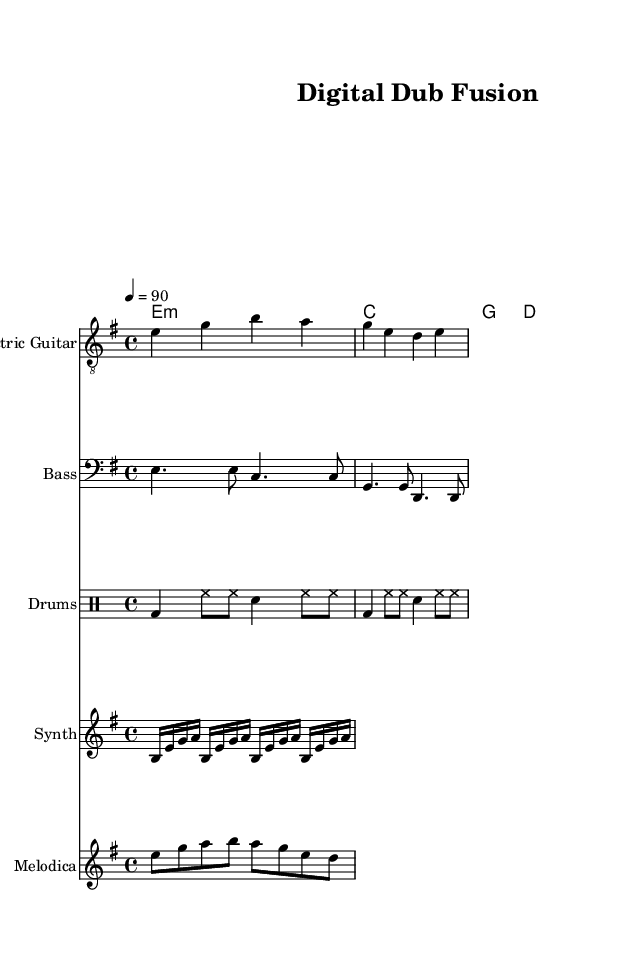What is the key signature of this music? The key signature is indicated at the beginning of the score, and a sharp symbol is shown for F, confirming that the piece is in E minor.
Answer: E minor What is the time signature? The time signature is displayed directly beneath the key signature at the start of the score, which is shown as 4/4, meaning there are four beats per measure.
Answer: 4/4 What is the tempo marking for this piece? The tempo is defined in the score with "4 = 90," indicating that there are 90 beats per minute, which provides the speed at which the piece should be played.
Answer: 90 How many measures does the electric guitar part have? By counting the measures in the electric guitar part, each measure is separated by a vertical bar, and there are a total of four measures present in the written music.
Answer: 4 What kind of instrumentation is used in this piece? The score lists specific instrument parts, including electric guitar, bass, drums, synth, and melodica, reflecting a fusion of traditional reggae sounds with modern digital elements.
Answer: Electric guitar, bass, drums, synth, and melodica Which chord is played in the first measure? The first measure shows a chord notation "e:m" above the electric guitar part, indicating that an E minor chord is played in that measure.
Answer: E minor What rhythmic pattern is predominant in the drums part? The drums part follows a pattern of bass drum and hi-hat combinations, where the bass drum is played on beats one and three, while the hi-hat plays continuously, establishing a solid reggae backbeat.
Answer: Bass drum and hi-hat pattern 